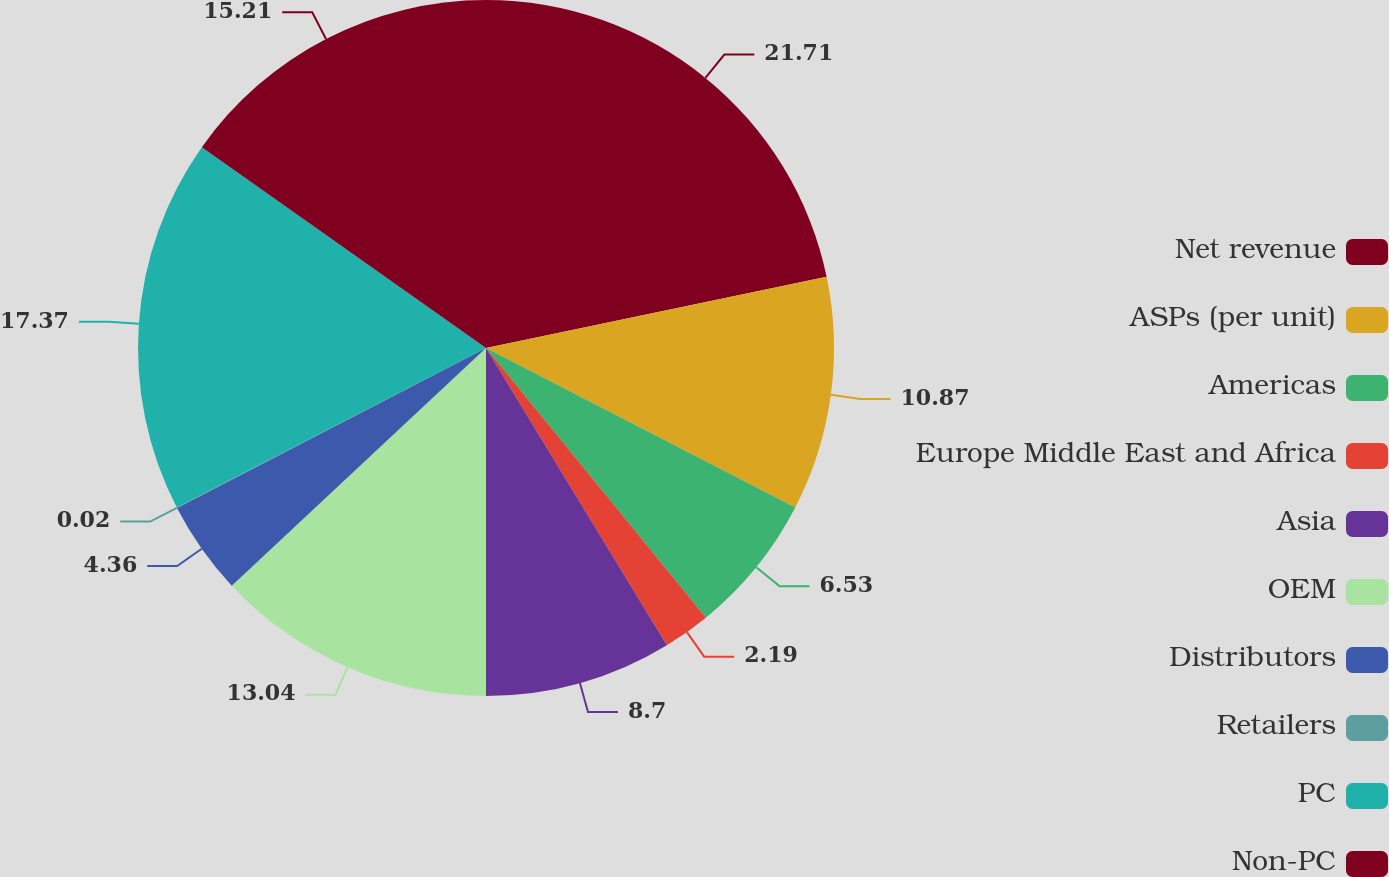Convert chart. <chart><loc_0><loc_0><loc_500><loc_500><pie_chart><fcel>Net revenue<fcel>ASPs (per unit)<fcel>Americas<fcel>Europe Middle East and Africa<fcel>Asia<fcel>OEM<fcel>Distributors<fcel>Retailers<fcel>PC<fcel>Non-PC<nl><fcel>21.72%<fcel>10.87%<fcel>6.53%<fcel>2.19%<fcel>8.7%<fcel>13.04%<fcel>4.36%<fcel>0.02%<fcel>17.38%<fcel>15.21%<nl></chart> 